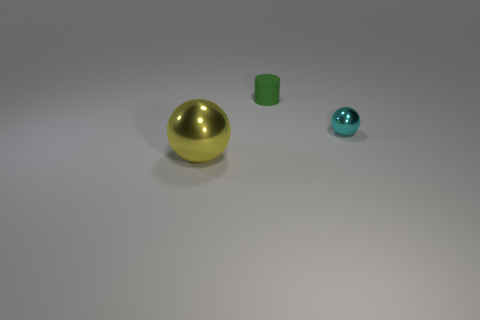Add 2 red blocks. How many objects exist? 5 Subtract all cylinders. How many objects are left? 2 Add 1 tiny green things. How many tiny green things exist? 2 Subtract 0 purple blocks. How many objects are left? 3 Subtract all green cubes. Subtract all cyan metal things. How many objects are left? 2 Add 2 tiny matte things. How many tiny matte things are left? 3 